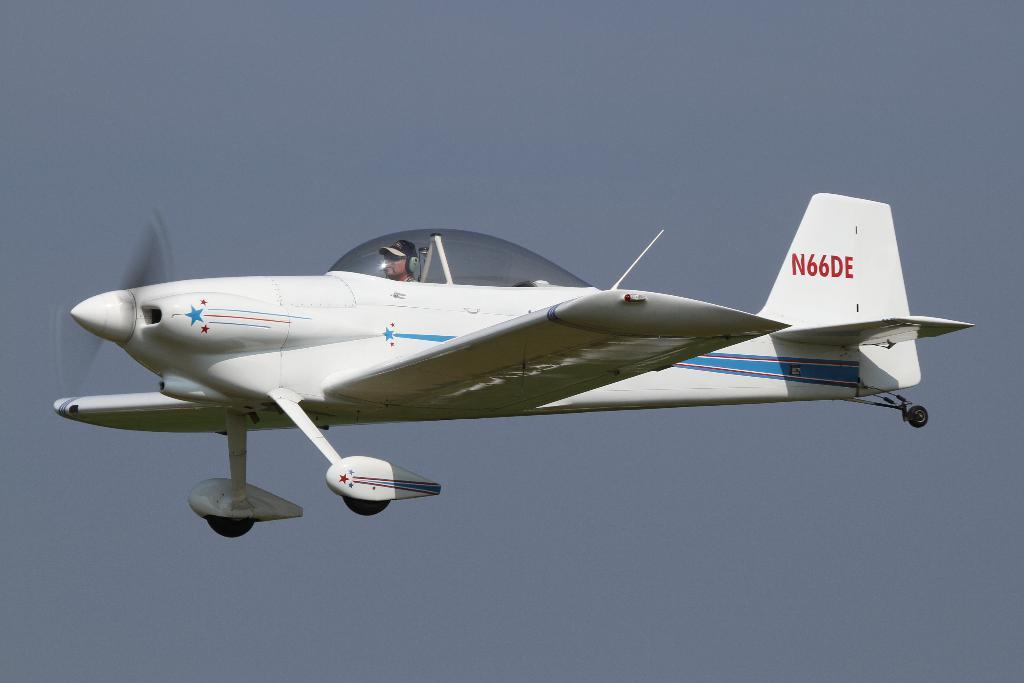Describe this image in one or two sentences. In the picture I can see one person is riding a plane in the air. 